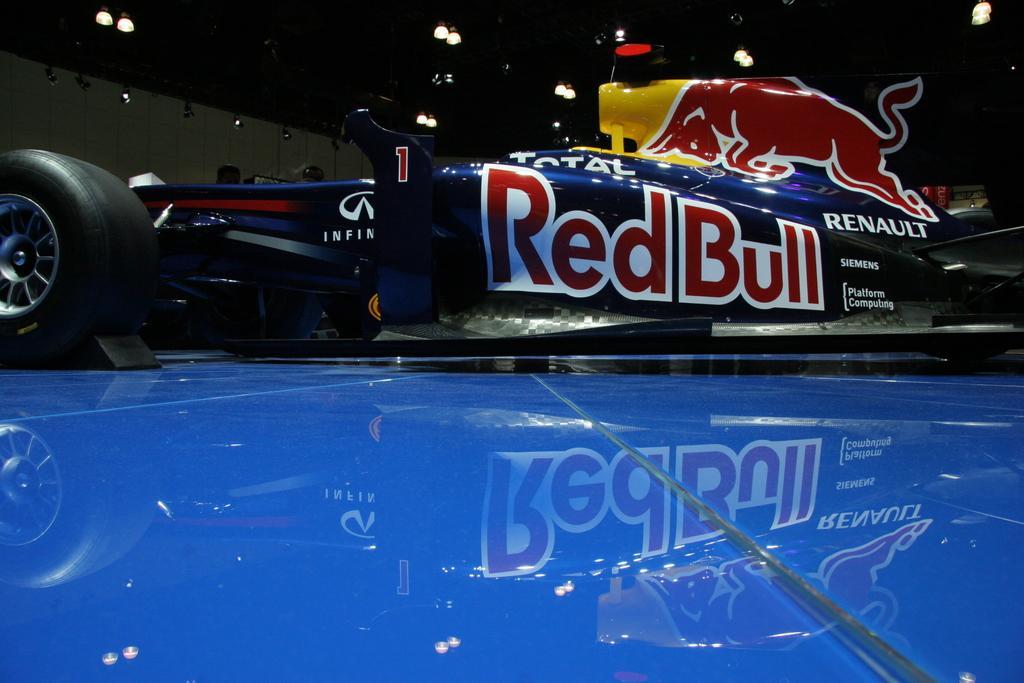Could you give a brief overview of what you see in this image? In this picture I can see a vehicle on a blue color surface. In the background I can see lights and a wall. 